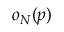<formula> <loc_0><loc_0><loc_500><loc_500>o _ { N } ( p )</formula> 